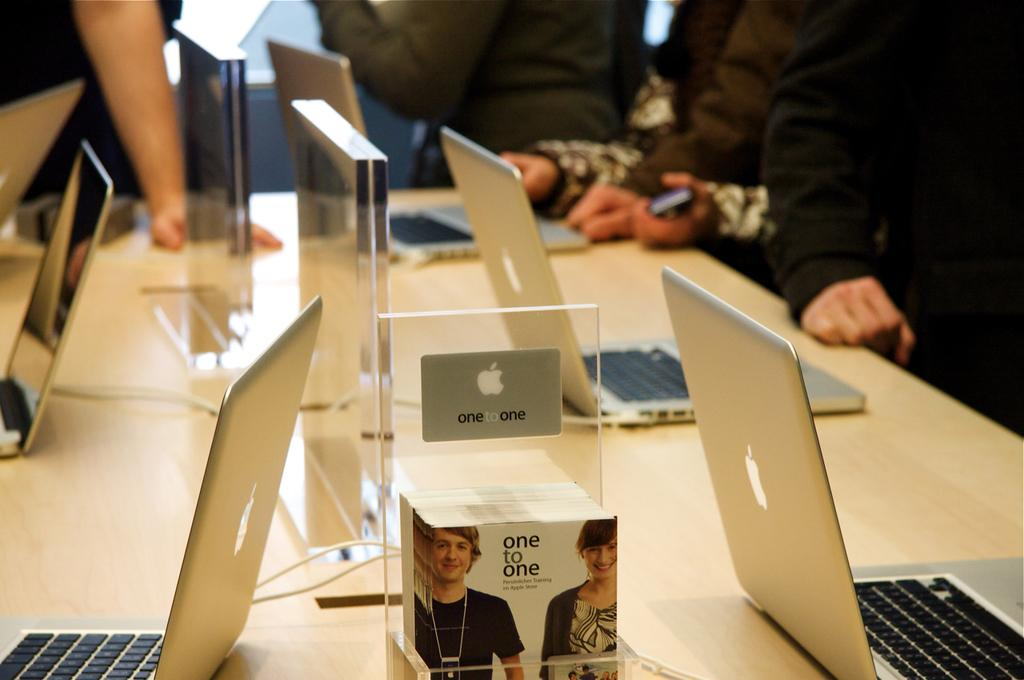Who or what can be seen in the image? There are people in the image. What object is visible in the image that might be used for eating or working? There is a table in the image. What electronic devices are on the table? MacBooks are present on the table. What else can be found on the table besides the MacBooks? Notepads are also present on the table. What type of cheese is being used to build the bridge in the image? There is no bridge or cheese present in the image. 